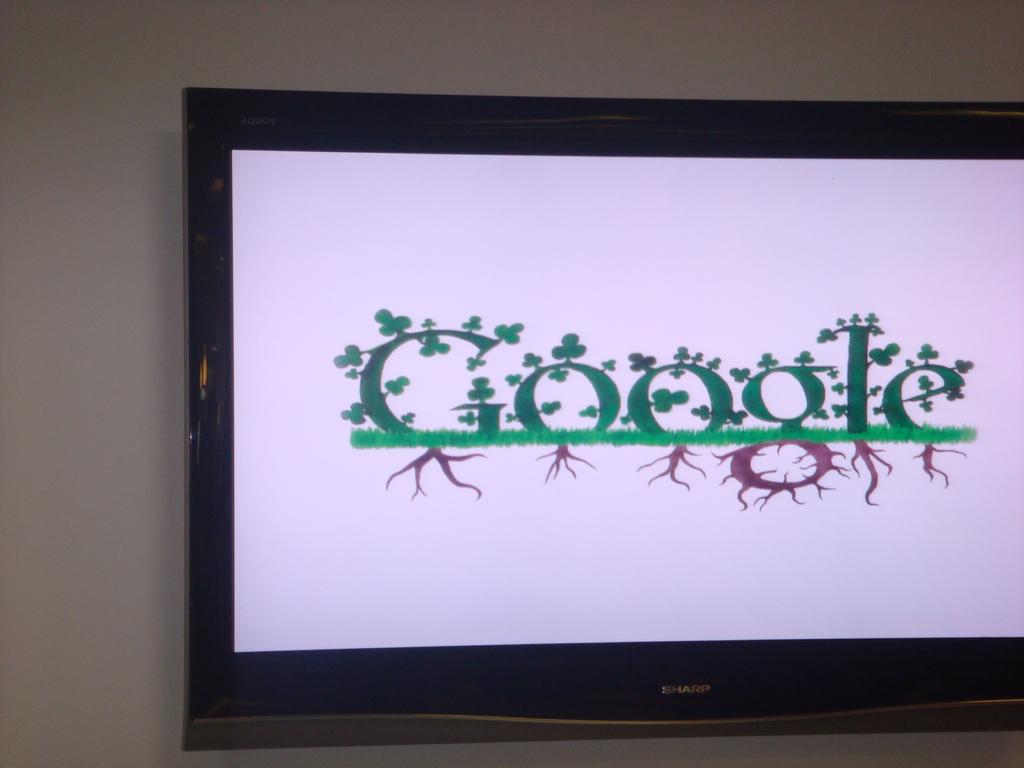What well known website is the screen depicting?
Your answer should be very brief. Google. 